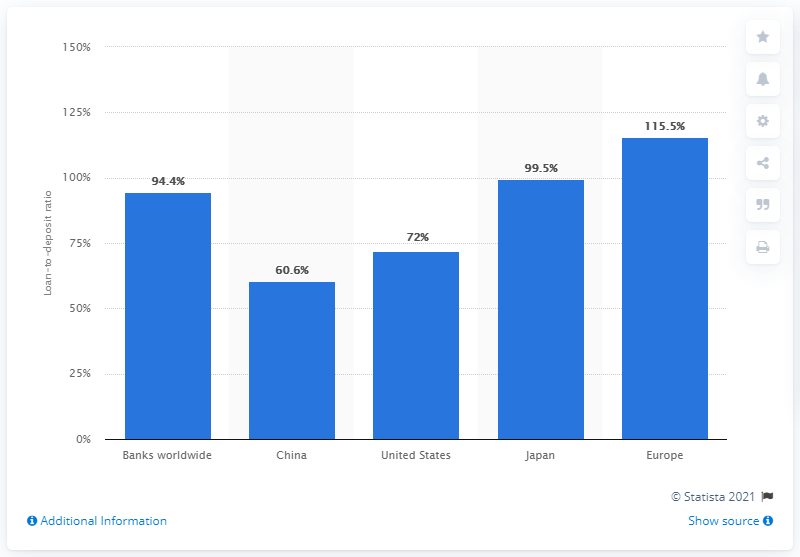Draw attention to some important aspects in this diagram. As of October 2011, the loan-to-deposit ratio in Japan was 99.5%, indicating that banks in the country had lent out 99.5% of their total deposits to borrowers. As of October 2011, the loan-deposit ratio in China was 60.6. As of October 2011, the loan-to-deposit ratio in the global bank industry was 99.5%, indicating that banks had lent out 99.5 cents for every dollar they had received in deposits. As of October 2011, the two countries with the highest and lowest loan-to-deposit ratios in the global bank industry were China with a ratio of 54.9 and the United States with a ratio of 81.2. 